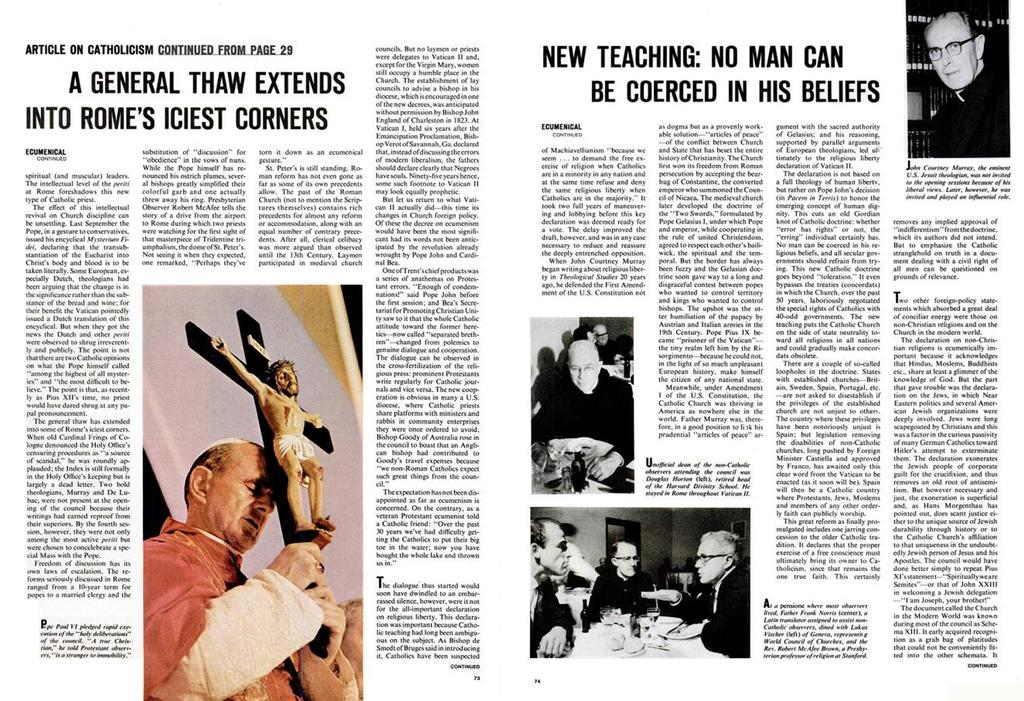What is present in the image that contains both images and text? There is a poster in the image that contains images and text. What type of soap is being advertised on the poster in the image? There is no soap being advertised on the poster in the image; the poster contains images and text, but no soap. 